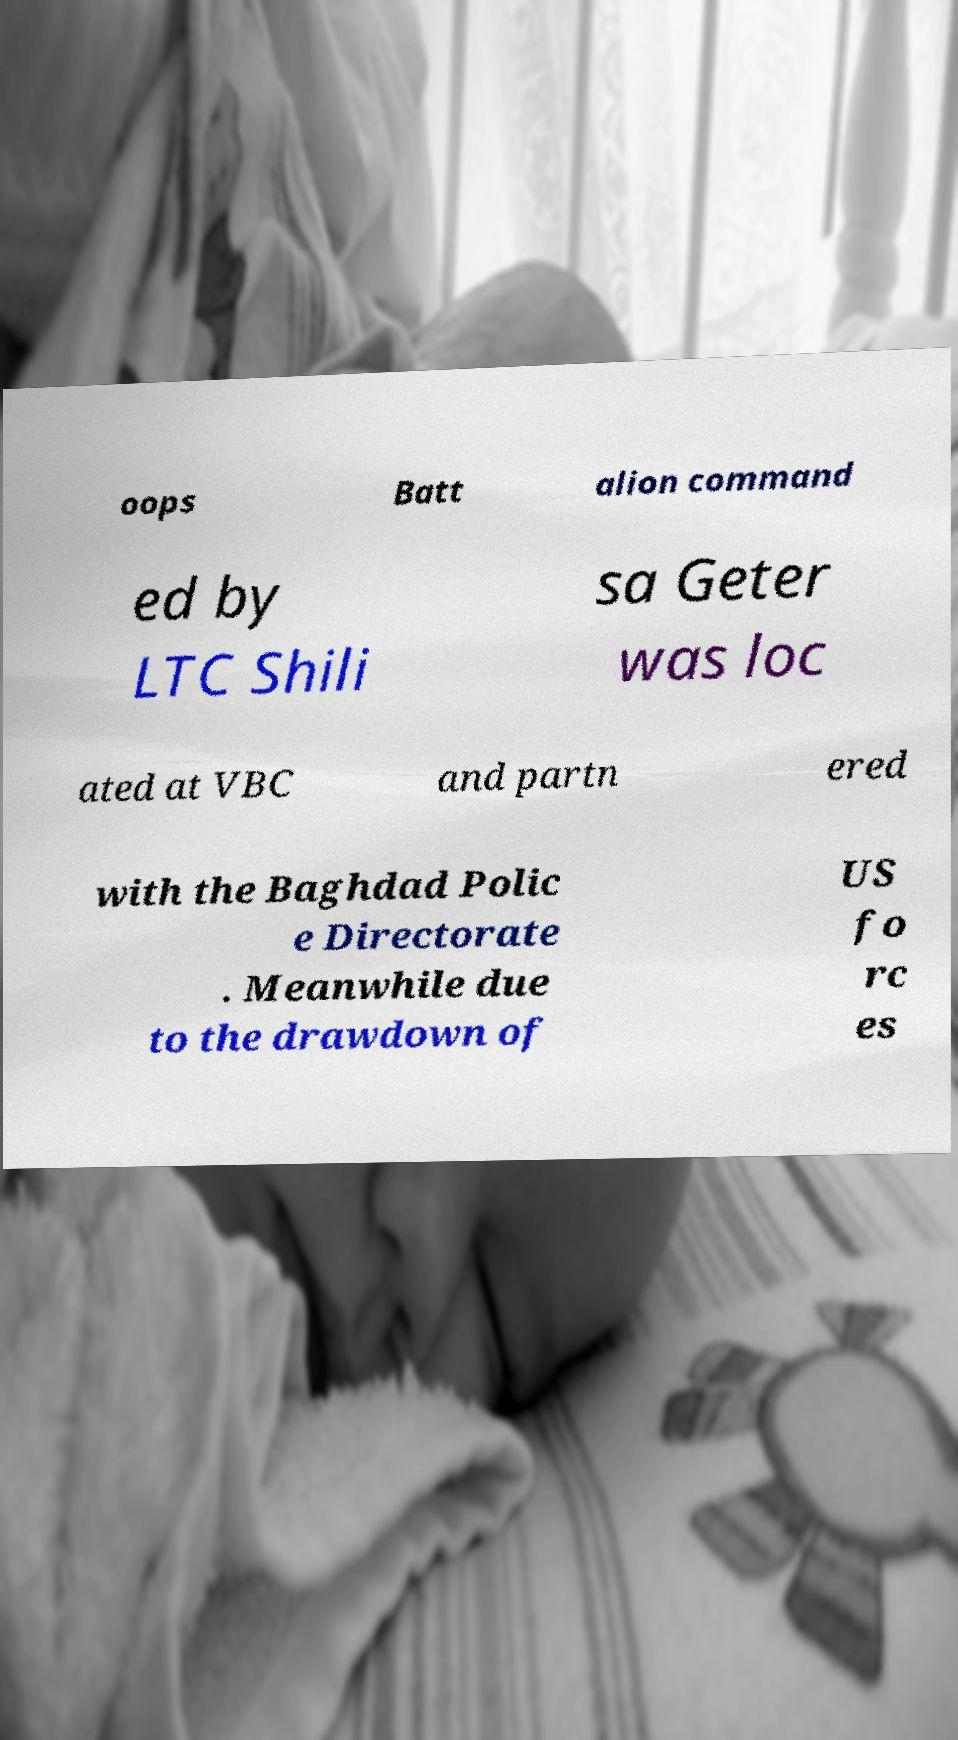Could you assist in decoding the text presented in this image and type it out clearly? oops Batt alion command ed by LTC Shili sa Geter was loc ated at VBC and partn ered with the Baghdad Polic e Directorate . Meanwhile due to the drawdown of US fo rc es 